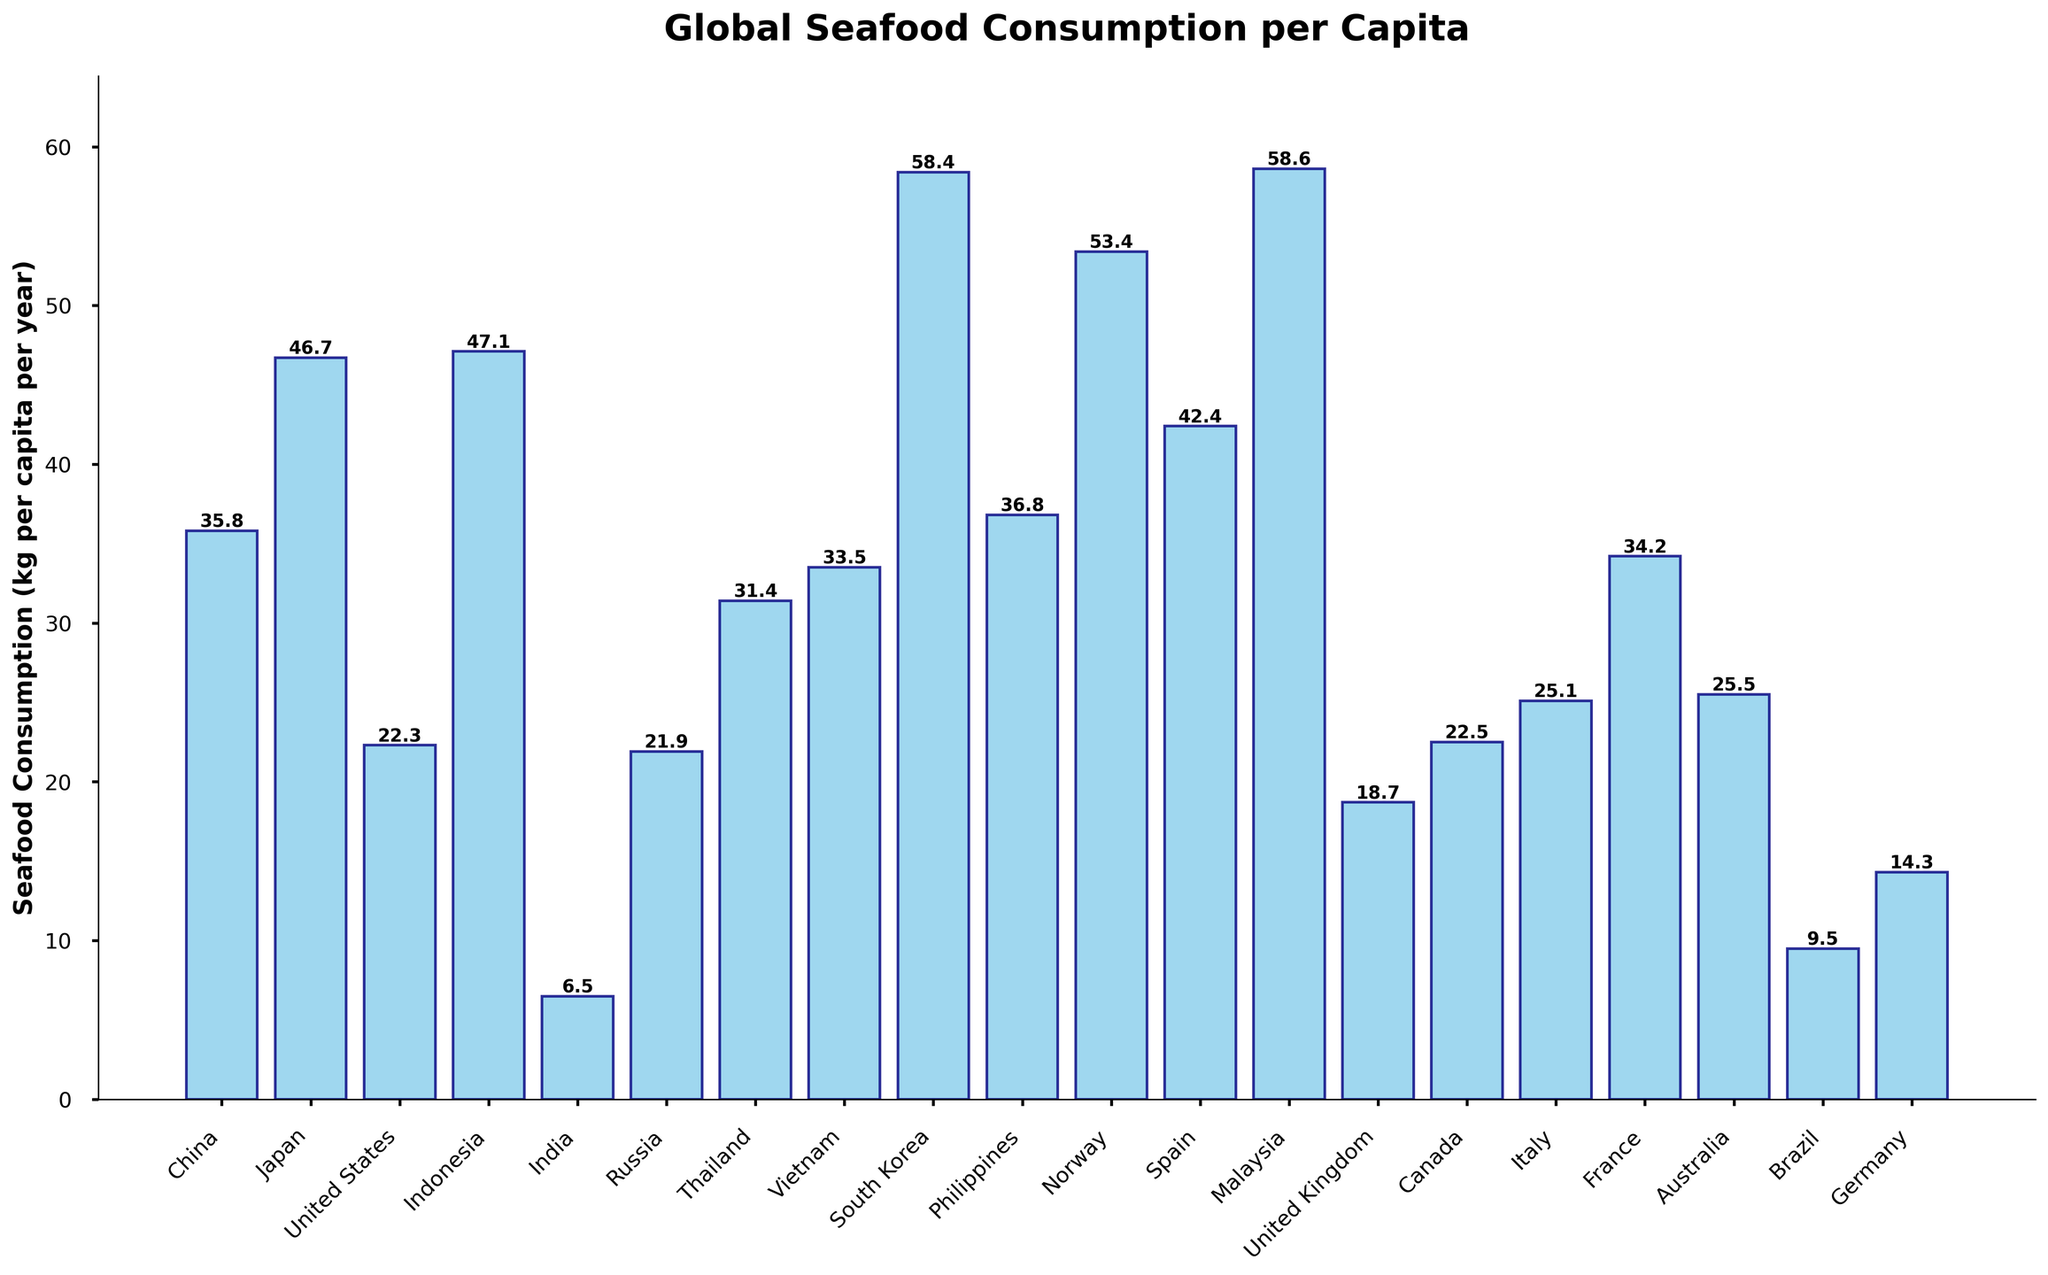Which country has the highest seafood consumption per capita? By observing the heights of the bars, the bar representing Malaysia is the tallest, indicating it has the highest seafood consumption per capita.
Answer: Malaysia Which country has the lowest seafood consumption per capita? By observing the heights of the bars, the bar representing India is the shortest, indicating it has the lowest seafood consumption per capita.
Answer: India What is the difference in seafood consumption per capita between South Korea and the United States? The bar for South Korea has a height of 58.4 kg, while the bar for the United States has a height of 22.3 kg. The difference is 58.4 - 22.3 = 36.1 kg.
Answer: 36.1 kg Which countries have seafood consumption per capita greater than 50 kg? By looking at the bars that have a height greater than 50 kg, South Korea (58.4 kg), Malaysia (58.6 kg), Norway (53.4 kg), and Indonesia (47.1 kg) are identified.
Answer: South Korea, Malaysia, Norway What is the sum of seafood consumption per capita for Vietnam, Spain, and Russia? The heights of the bars for Vietnam, Spain, and Russia are 33.5 kg, 42.4 kg, and 21.9 kg respectively. Summing them up gives 33.5 + 42.4 + 21.9 = 97.8 kg.
Answer: 97.8 kg Which country has marginally higher seafood consumption, Japan or Spain? The bar for Japan has a height of 46.7 kg, while the bar for Spain has a height of 42.4 kg. Japan's consumption is marginally higher.
Answer: Japan What is the average seafood consumption per capita among the top three consuming countries? The top three countries are Malaysia (58.6 kg), South Korea (58.4 kg), and Norway (53.4 kg). Their average consumption is (58.6 + 58.4 + 53.4) / 3 = 56.8 kg.
Answer: 56.8 kg How does the seafood consumption in China compare to that in Vietnam? The bar for China has a height of 35.8 kg, while the bar for Vietnam has a height of 33.5 kg. China has a higher seafood consumption than Vietnam.
Answer: China What is the total seafood consumption per capita for Canada, Australia, and France combined? The heights of the bars for Canada, Australia, and France are 22.5 kg, 25.5 kg, and 34.2 kg respectively. Summing them gives 22.5 + 25.5 + 34.2 = 82.2 kg.
Answer: 82.2 kg 